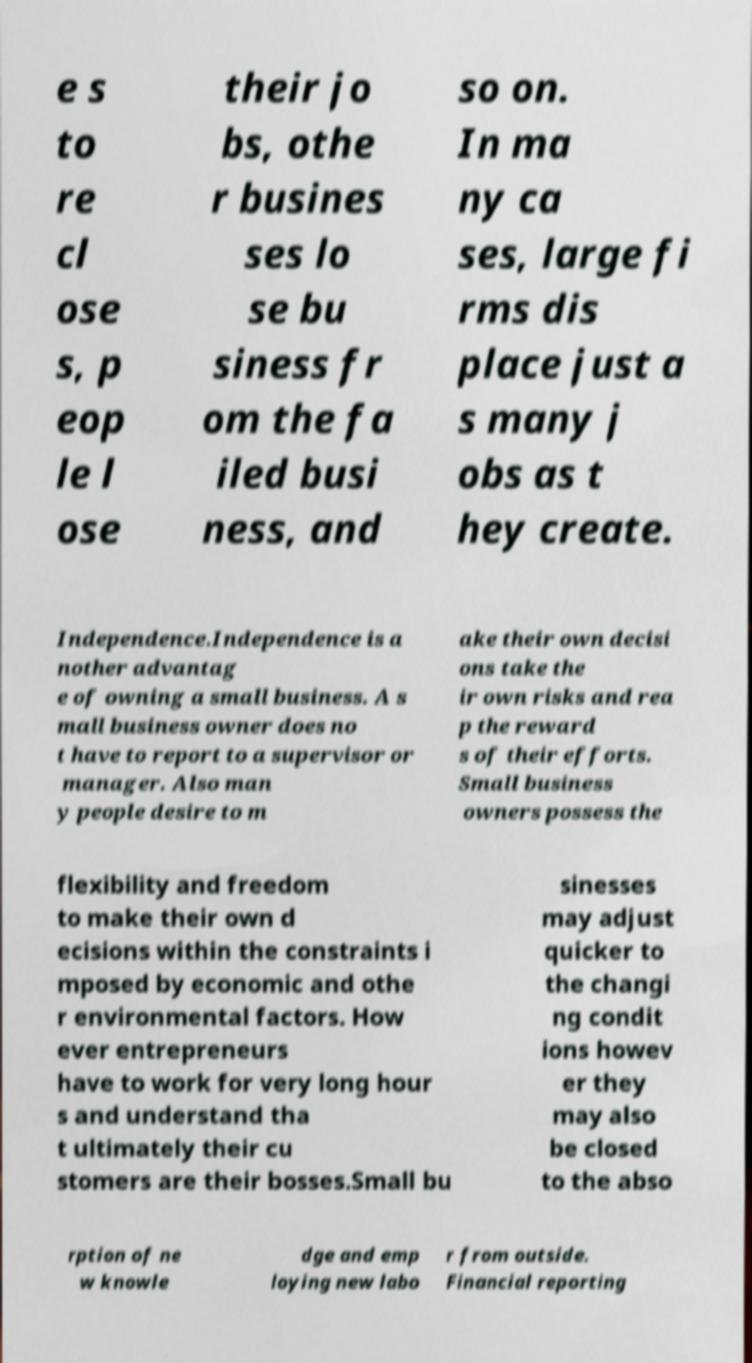There's text embedded in this image that I need extracted. Can you transcribe it verbatim? e s to re cl ose s, p eop le l ose their jo bs, othe r busines ses lo se bu siness fr om the fa iled busi ness, and so on. In ma ny ca ses, large fi rms dis place just a s many j obs as t hey create. Independence.Independence is a nother advantag e of owning a small business. A s mall business owner does no t have to report to a supervisor or manager. Also man y people desire to m ake their own decisi ons take the ir own risks and rea p the reward s of their efforts. Small business owners possess the flexibility and freedom to make their own d ecisions within the constraints i mposed by economic and othe r environmental factors. How ever entrepreneurs have to work for very long hour s and understand tha t ultimately their cu stomers are their bosses.Small bu sinesses may adjust quicker to the changi ng condit ions howev er they may also be closed to the abso rption of ne w knowle dge and emp loying new labo r from outside. Financial reporting 